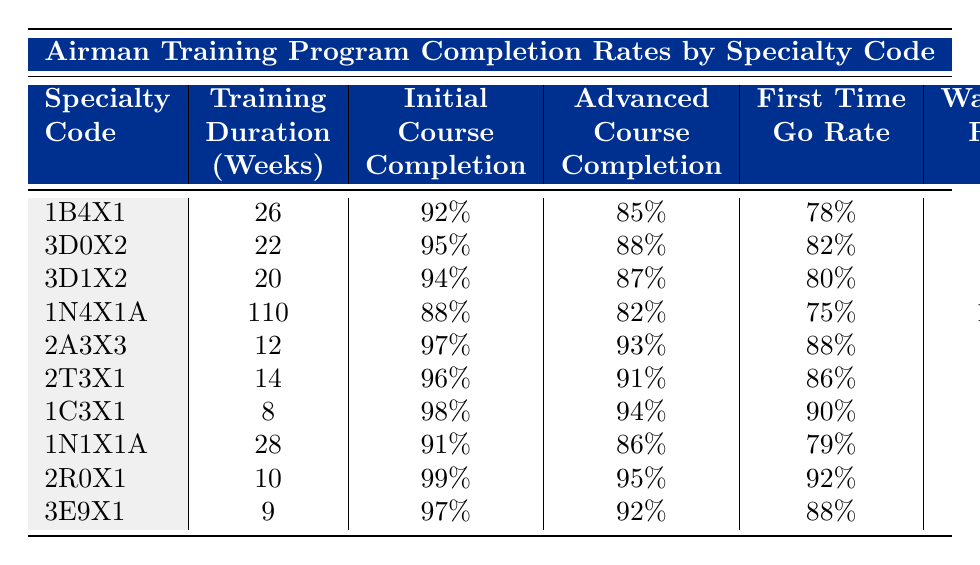What is the washout rate for the 3D0X2 specialty code? The washout rate is directly listed in the table under the corresponding column for the 3D0X2 specialty code. It shows a washout rate of 5%.
Answer: 5% Which specialty has the highest initial skills course completion rate? The initial skills course completion rates can be found in the respective column for each specialty. The highest rate is 99% for the 2R0X1 specialty code.
Answer: 2R0X1 How many annual graduates are there for the Fusion Analyst specialty? By checking the annual graduates column corresponding to the Fusion Analyst specialty (1N4X1A), we see there are 200 annual graduates.
Answer: 200 What is the average training duration of the specialties listed in the table? To find the average training duration, we sum the durations (26 + 22 + 20 + 110 + 12 + 14 + 8 + 28 + 10 + 9 =  329 weeks) and divide by the number of specialties (10). The calculated average is 329/10 = 32.9 weeks.
Answer: 32.9 weeks Is the average ASVAB score for the Tactical Aircraft Maintenance specialty higher than 75? The average ASVAB score for Tactical Aircraft Maintenance (2A3X3) is 72, which is less than 75.
Answer: No What is the relationship between training duration and the initial skills course completion rate? By examining the training duration and initial skills course completion rate columns, we observe that longer training durations do not consistently correlate with higher completion rates. For instance, the Fusion Analyst specialty has a significantly longer duration but a lower completion rate than the 2R0X1 specialty. The data does not indicate a straightforward relationship.
Answer: No straightforward relationship How many specialties have a first time go rate of 90% or higher? Checking the first time go rate column, we find the specialties with rates of 90% or higher are: 1C3X1 (90%), 2R0X1 (92%), and 2A3X3 (88%), which gives us a total of 3 specialties.
Answer: 3 What is the difference in annual graduates between Cyber Warfare Operations (1B4X1) and Vehicle Maintenance (2T3X1)? We look at the annual graduates for Cyber Warfare Operations, which is 450, and Vehicle Maintenance, which is 350. The difference is 450 - 350 = 100.
Answer: 100 Which specialty has the lowest advanced course completion rate? By checking the advanced course completion rate column, the specialty with the lowest completion rate is 1N4X1A (Fusion Analyst) at 82%.
Answer: 1N4X1A How does the first time go rate compare between specialties trained at Keesler AFB? The specialties trained at Keesler AFB are 1B4X1, 3D0X2, 3D1X2, and 1C3X1, with first time go rates of 78%, 82%, 80%, and 90% respectively. The average of these rates is (78 + 82 + 80 + 90)/4 = 82.5%.
Answer: Average is 82.5% Which specialty exhibits the best performance in regard to both initial skills course and washout rates? We evaluate both metrics, identifying that 2R0X1 has the highest initial skills course completion rate (99%) and the lowest washout rate (1%), indicating superior performance in both areas.
Answer: 2R0X1 